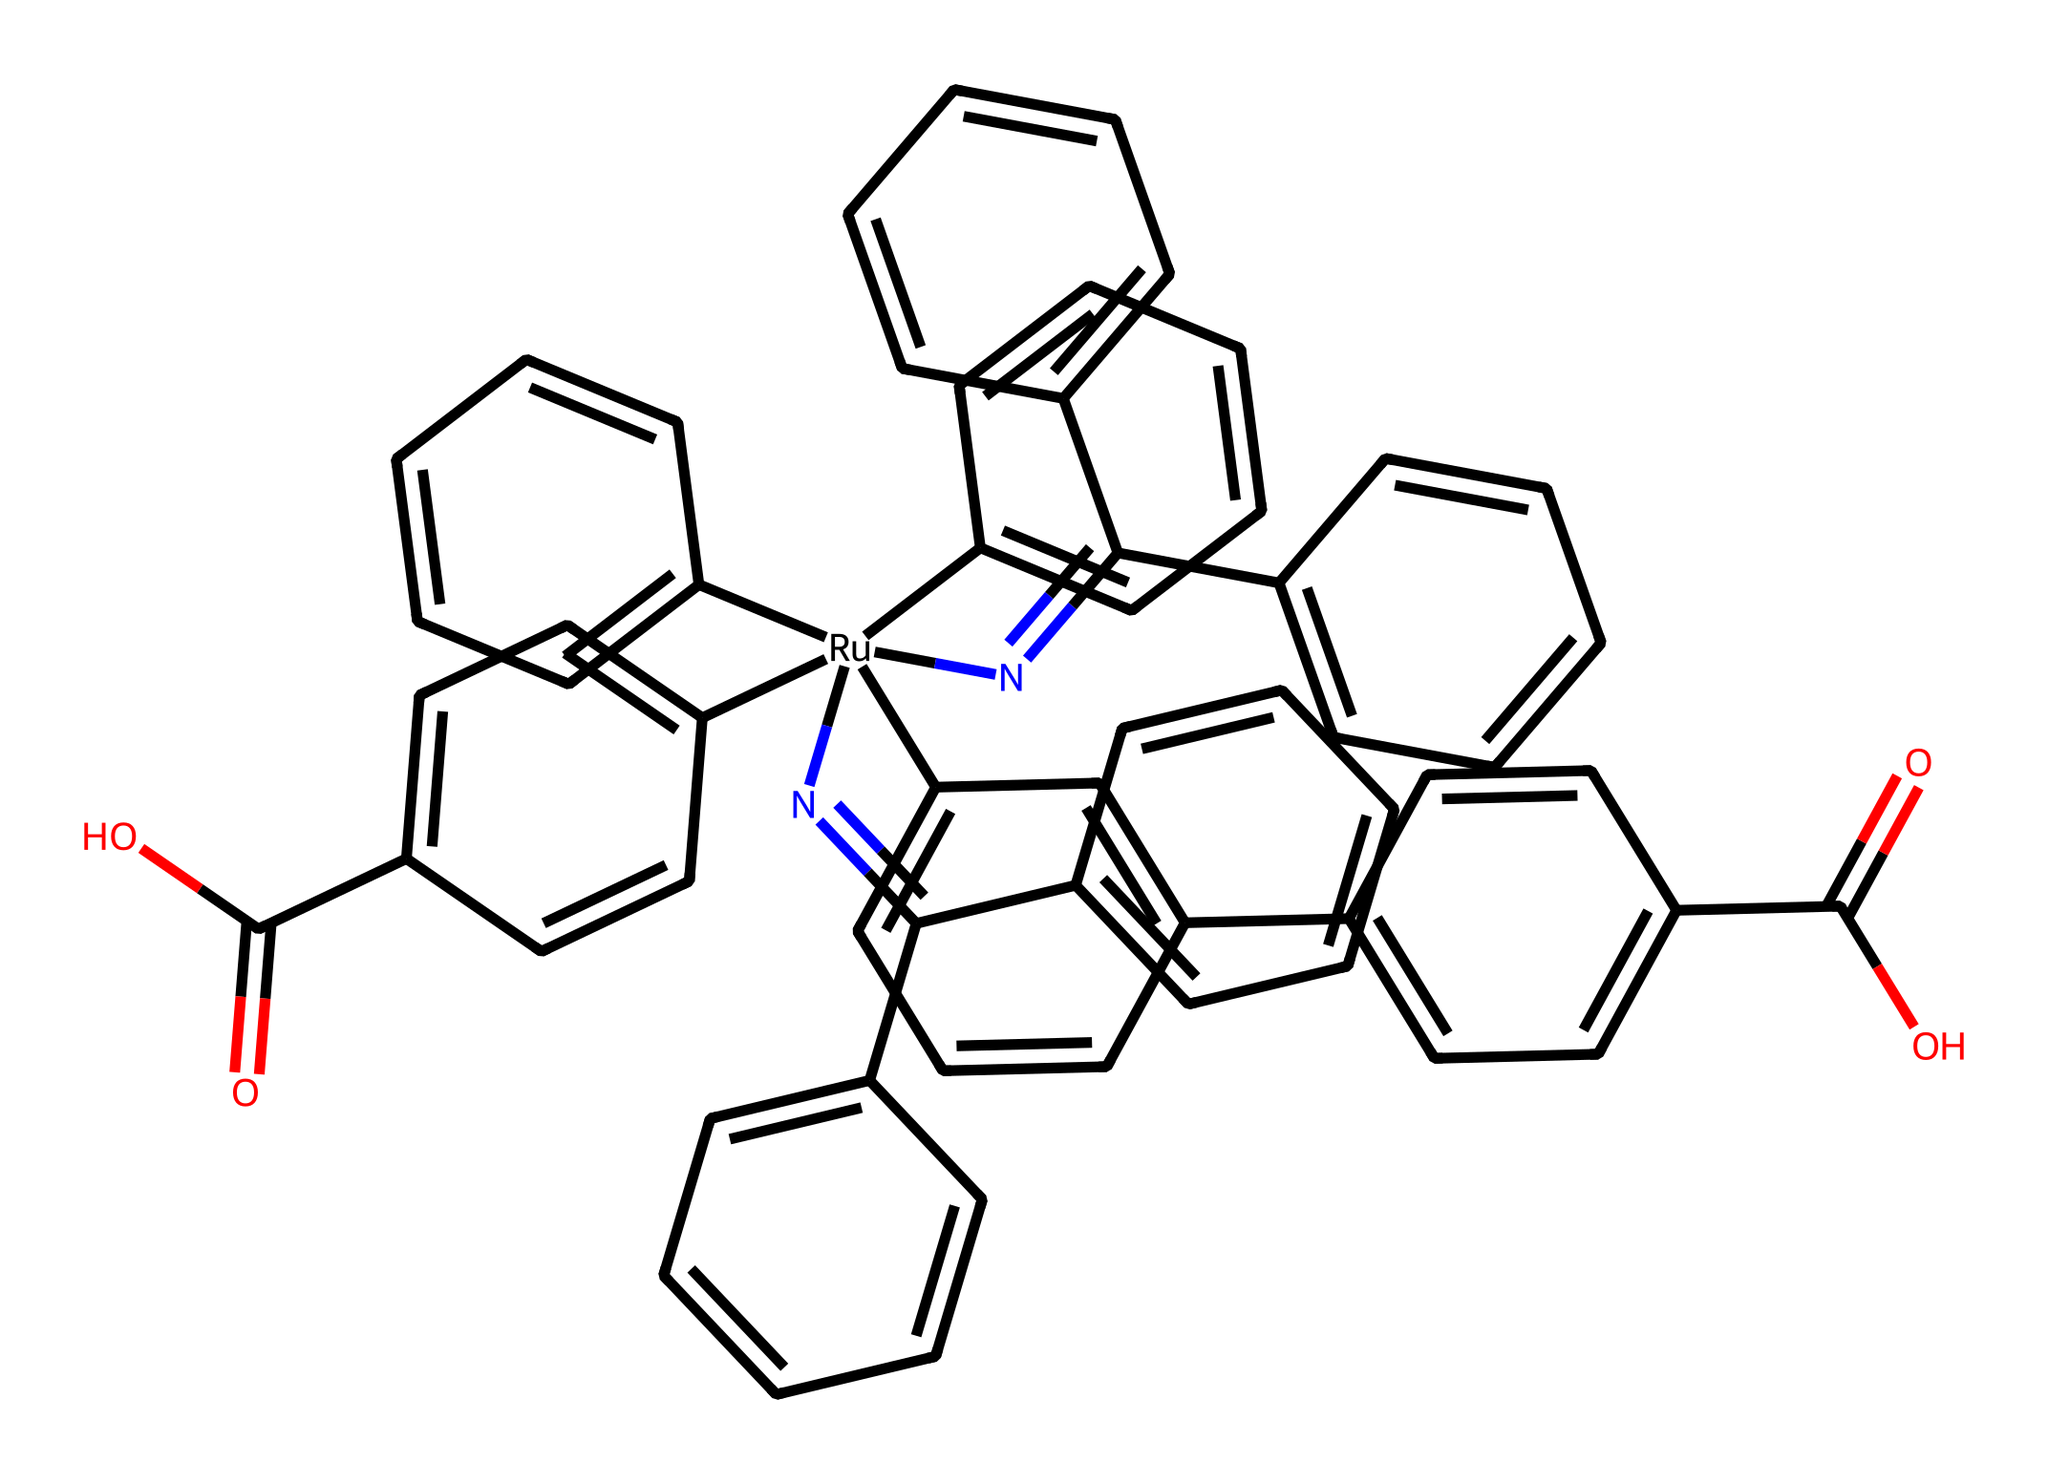What is the central metal in this coordination complex? The central metal in the coordination complex can be identified by looking for the atom around which ligands are coordinated. In this structure, ruthenium (Ru) is present at the core, confirming it as the central metal.
Answer: ruthenium How many distinct ligands are attached to the ruthenium? By analyzing the SMILES representation and counting the different chemical groups that are directly bonded to the ruthenium atom, it is determined that there are five distinct ligands, which are various substituted aromatic rings and functional groups.
Answer: five What type of structure does this coordination compound represent? This coordination compound represents a dye, specifically a ruthenium-based dye used for dye-sensitized solar cells. This is derived from the presence of the ruthenium central atom and the organic ligands associated with dye chemistry.
Answer: dye How many double bonds are present in this chemical structure? To determine the number of double bonds, you need to visualize the connections within the ligands. Counting the double bonds in the aromatic systems and other groups reveals that this chemical has a total of ten double bonds.
Answer: ten What functional groups are present in this compound? Functional groups can be identified by examining the structure for common organic functional groups. Here, carboxylic acid groups (-COOH) are present in the ligands of the complex.
Answer: carboxylic acid What is the overall charge of this coordination complex? To find the overall charge, consider the oxidation state of ruthenium and the contributions of the ligands. Given that each -COOH group contributes a negative charge, the overall charge is calculated to be neutral.
Answer: neutral How does the presence of multiple aromatic rings affect the stability of the complex? The stability of the complex is enhanced by the presence of multiple aromatic rings, as they contribute to delocalization and resonance stabilization. Each aromatic ring provides electronic effects that help stabilize the coordination sphere around the metal center.
Answer: enhanced stability 